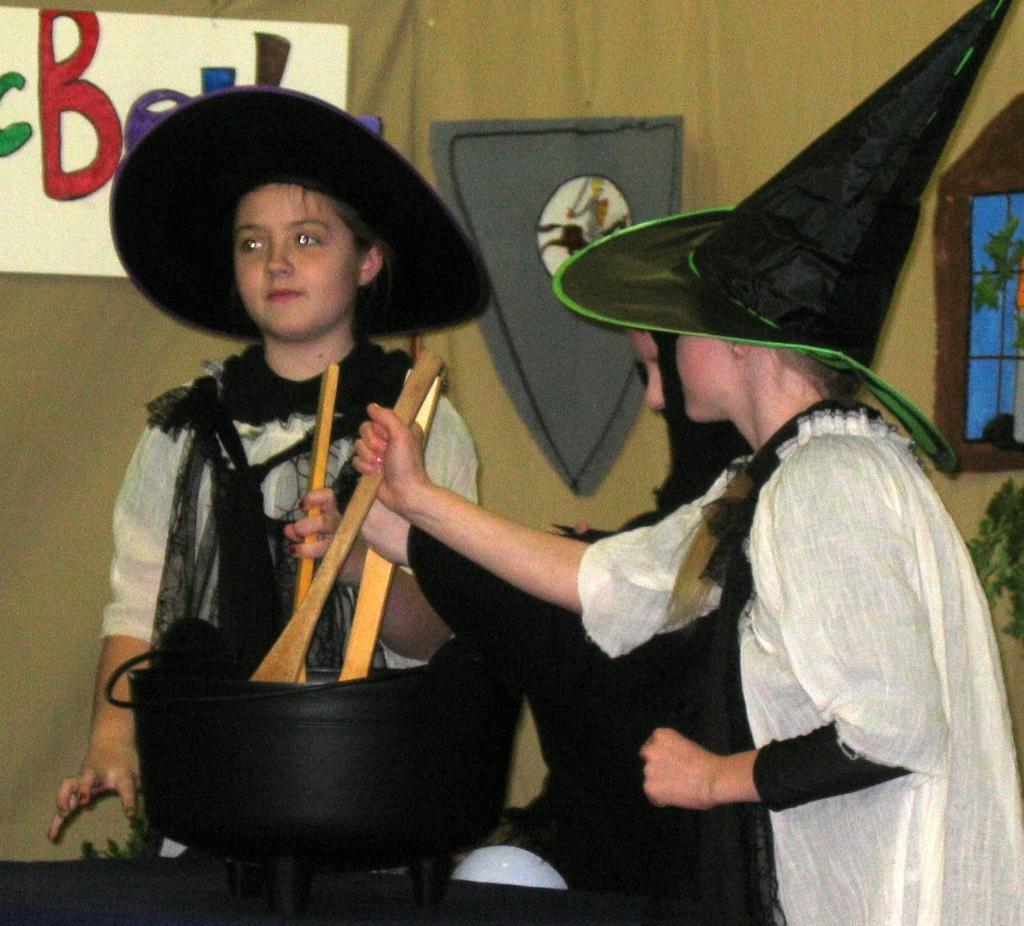Describe this image in one or two sentences. In the image I can see children are standing. They are wearing black color hats and holding some objects in hands. In the background I can see some objects attached to the wall. 